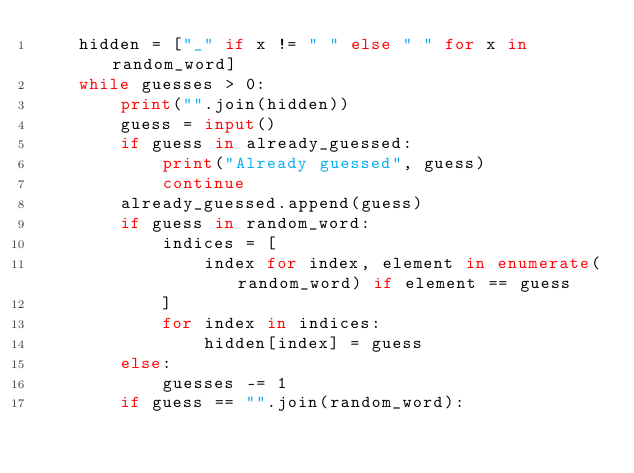Convert code to text. <code><loc_0><loc_0><loc_500><loc_500><_Python_>    hidden = ["_" if x != " " else " " for x in random_word]
    while guesses > 0:
        print("".join(hidden))
        guess = input()
        if guess in already_guessed:
            print("Already guessed", guess)
            continue
        already_guessed.append(guess)
        if guess in random_word:
            indices = [
                index for index, element in enumerate(random_word) if element == guess
            ]
            for index in indices:
                hidden[index] = guess
        else:
            guesses -= 1
        if guess == "".join(random_word):</code> 